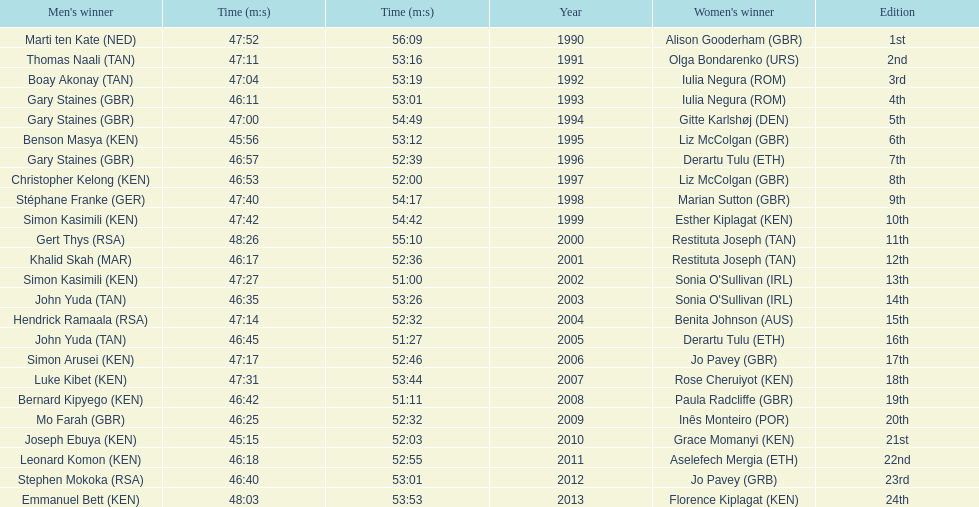What years were the races held? 1990, 1991, 1992, 1993, 1994, 1995, 1996, 1997, 1998, 1999, 2000, 2001, 2002, 2003, 2004, 2005, 2006, 2007, 2008, 2009, 2010, 2011, 2012, 2013. Who was the woman's winner of the 2003 race? Sonia O'Sullivan (IRL). What was her time? 53:26. 